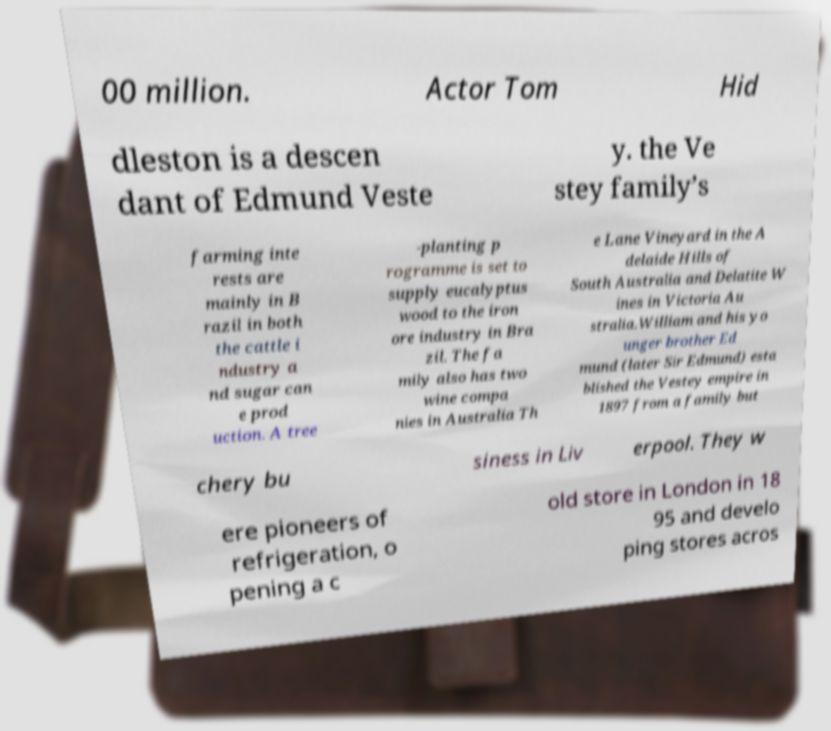Can you read and provide the text displayed in the image?This photo seems to have some interesting text. Can you extract and type it out for me? 00 million. Actor Tom Hid dleston is a descen dant of Edmund Veste y. the Ve stey family’s farming inte rests are mainly in B razil in both the cattle i ndustry a nd sugar can e prod uction. A tree -planting p rogramme is set to supply eucalyptus wood to the iron ore industry in Bra zil. The fa mily also has two wine compa nies in Australia Th e Lane Vineyard in the A delaide Hills of South Australia and Delatite W ines in Victoria Au stralia.William and his yo unger brother Ed mund (later Sir Edmund) esta blished the Vestey empire in 1897 from a family but chery bu siness in Liv erpool. They w ere pioneers of refrigeration, o pening a c old store in London in 18 95 and develo ping stores acros 